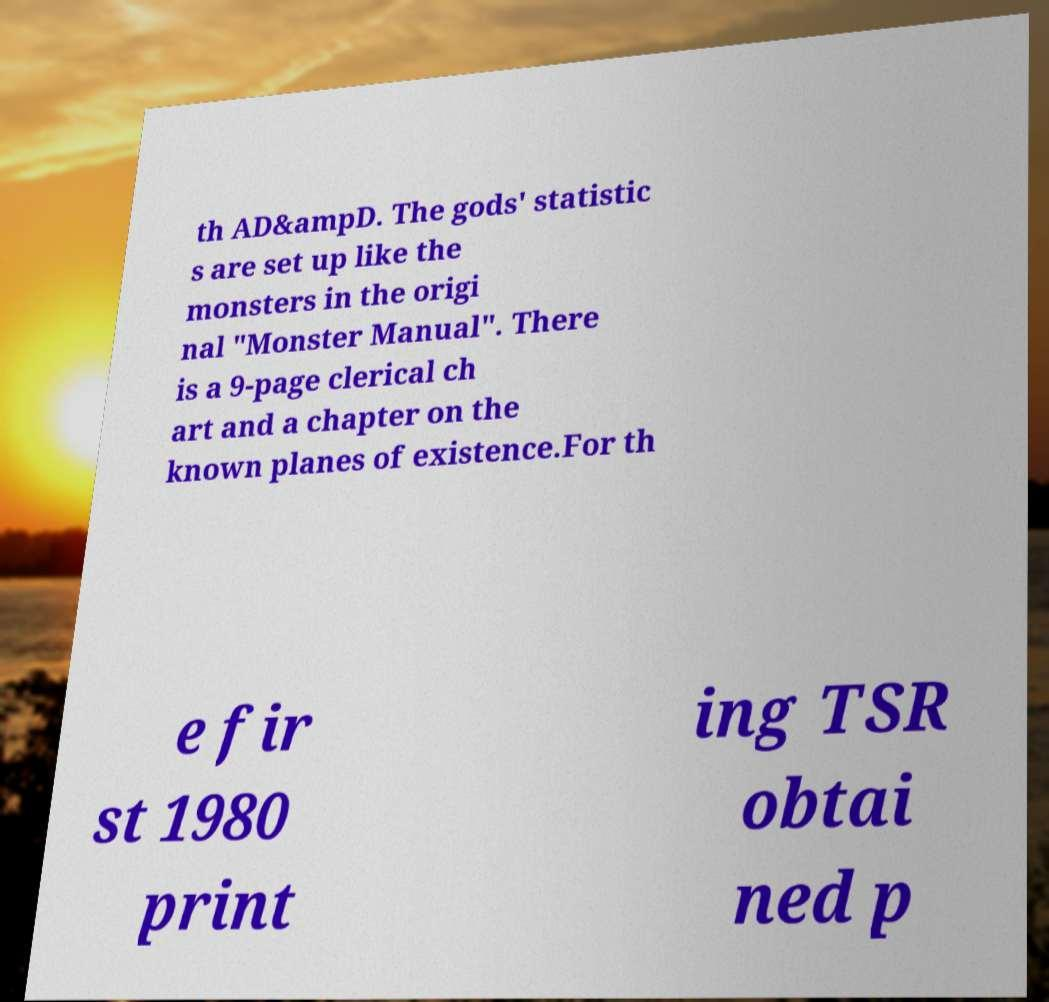Can you accurately transcribe the text from the provided image for me? th AD&ampD. The gods' statistic s are set up like the monsters in the origi nal "Monster Manual". There is a 9-page clerical ch art and a chapter on the known planes of existence.For th e fir st 1980 print ing TSR obtai ned p 